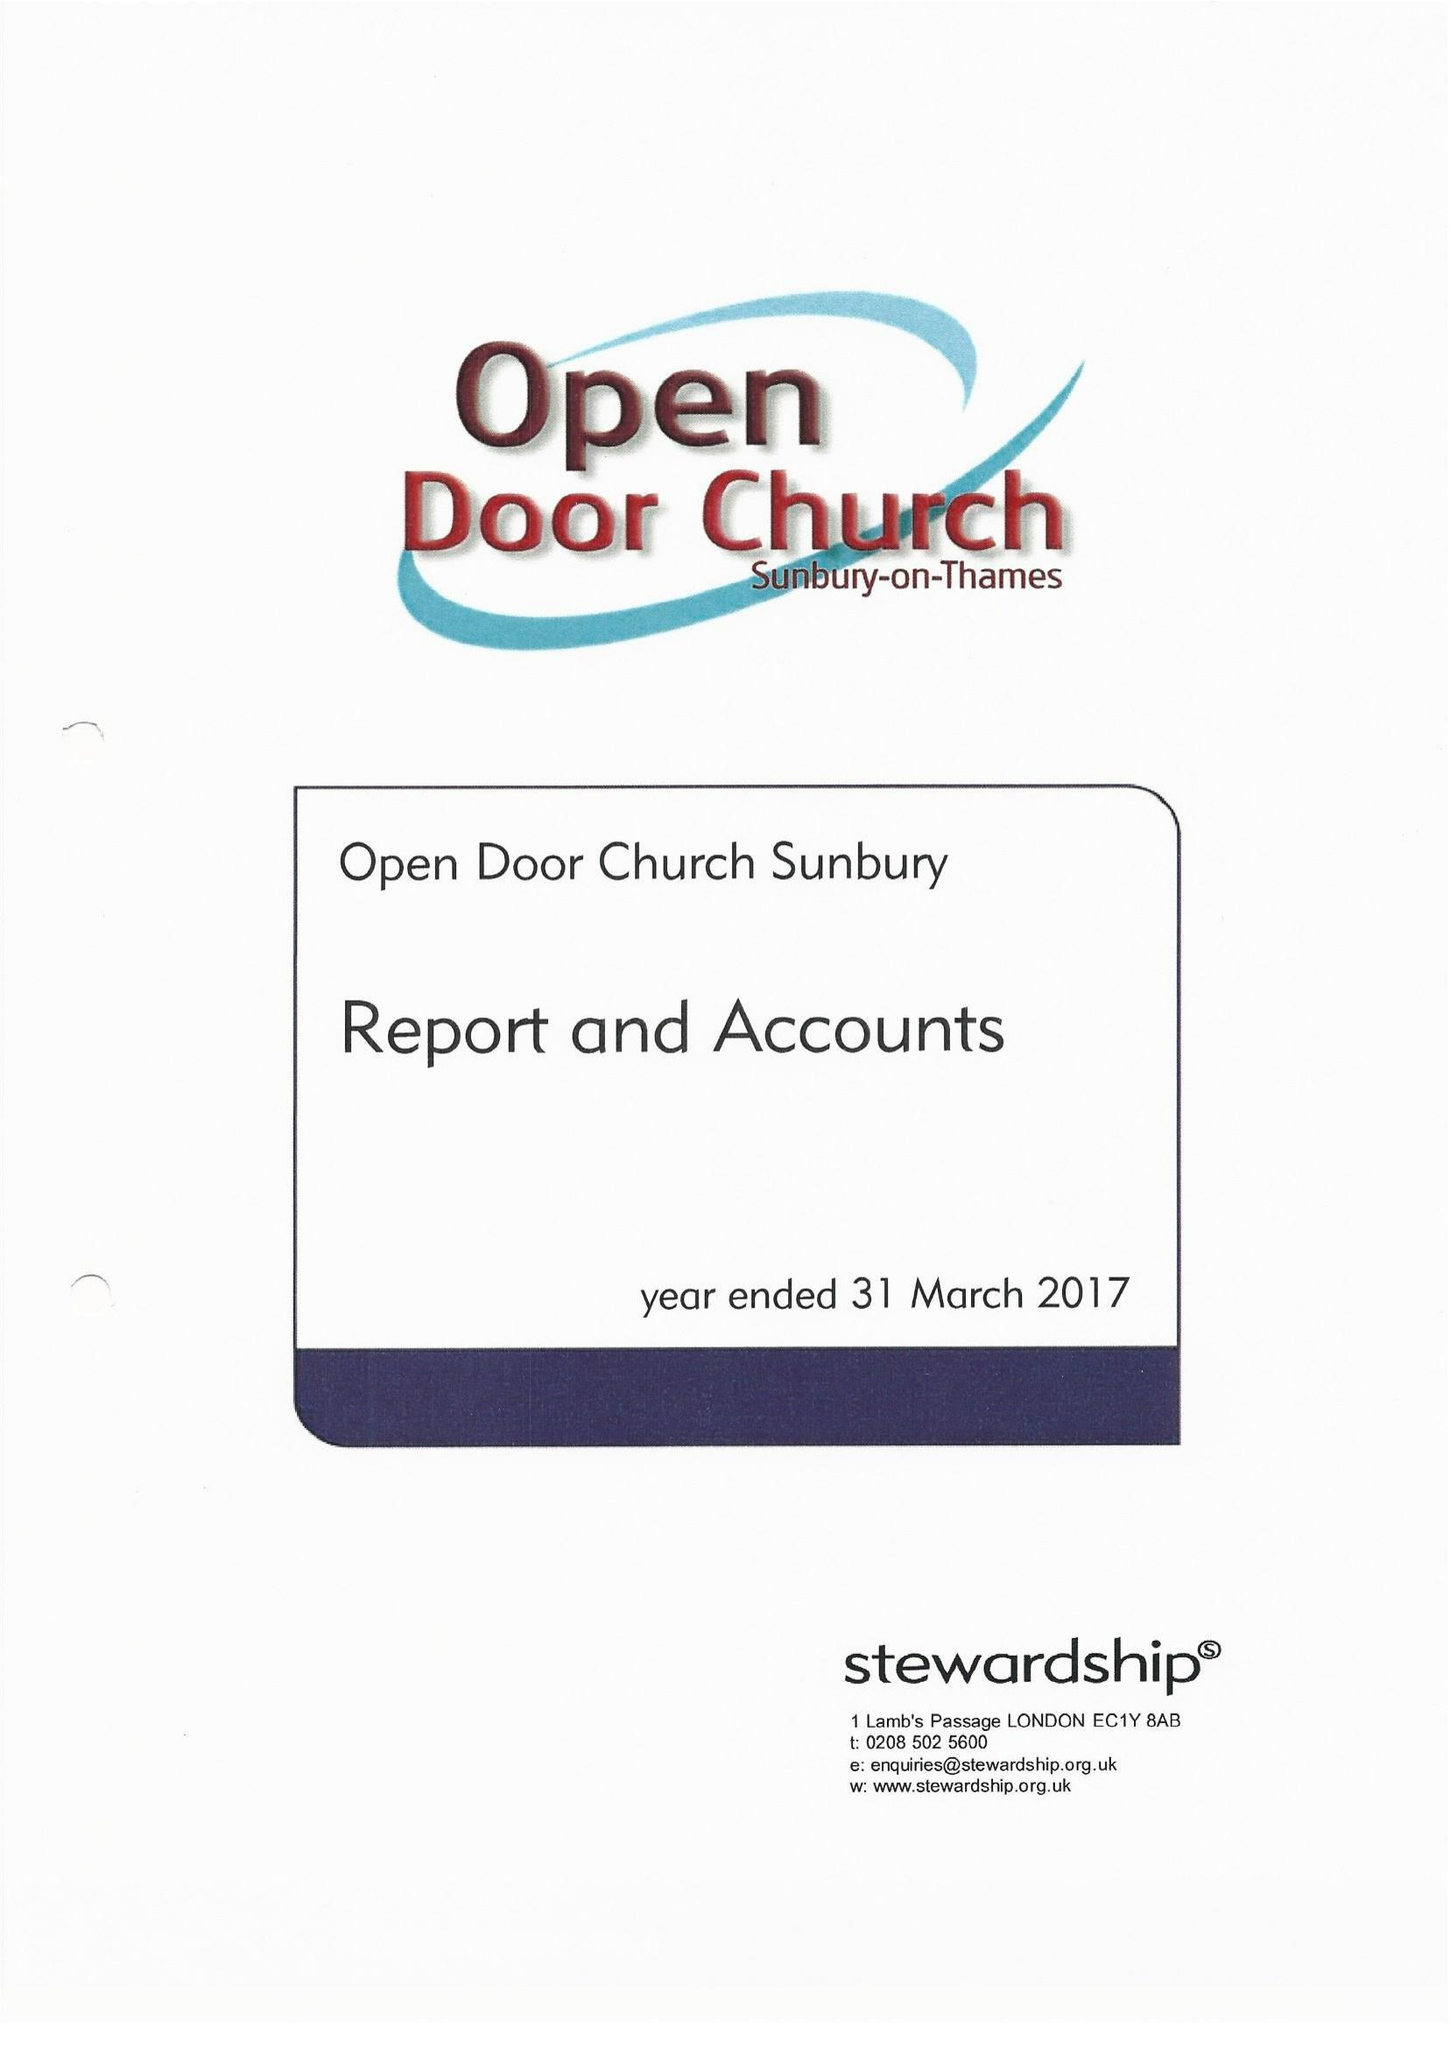What is the value for the charity_number?
Answer the question using a single word or phrase. 1079168 